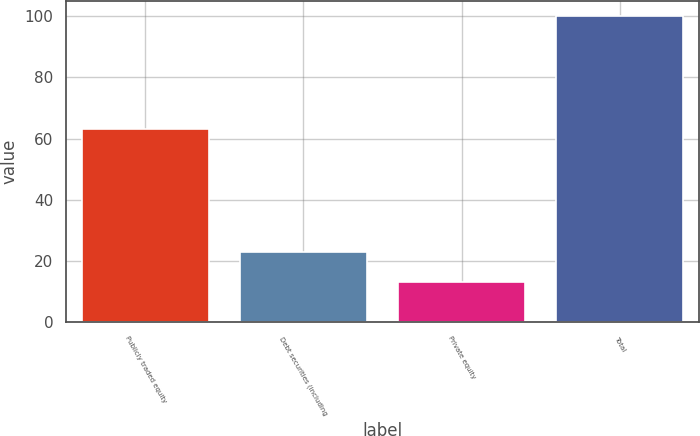Convert chart. <chart><loc_0><loc_0><loc_500><loc_500><bar_chart><fcel>Publicly traded equity<fcel>Debt securities (including<fcel>Private equity<fcel>Total<nl><fcel>63<fcel>23<fcel>13<fcel>100<nl></chart> 